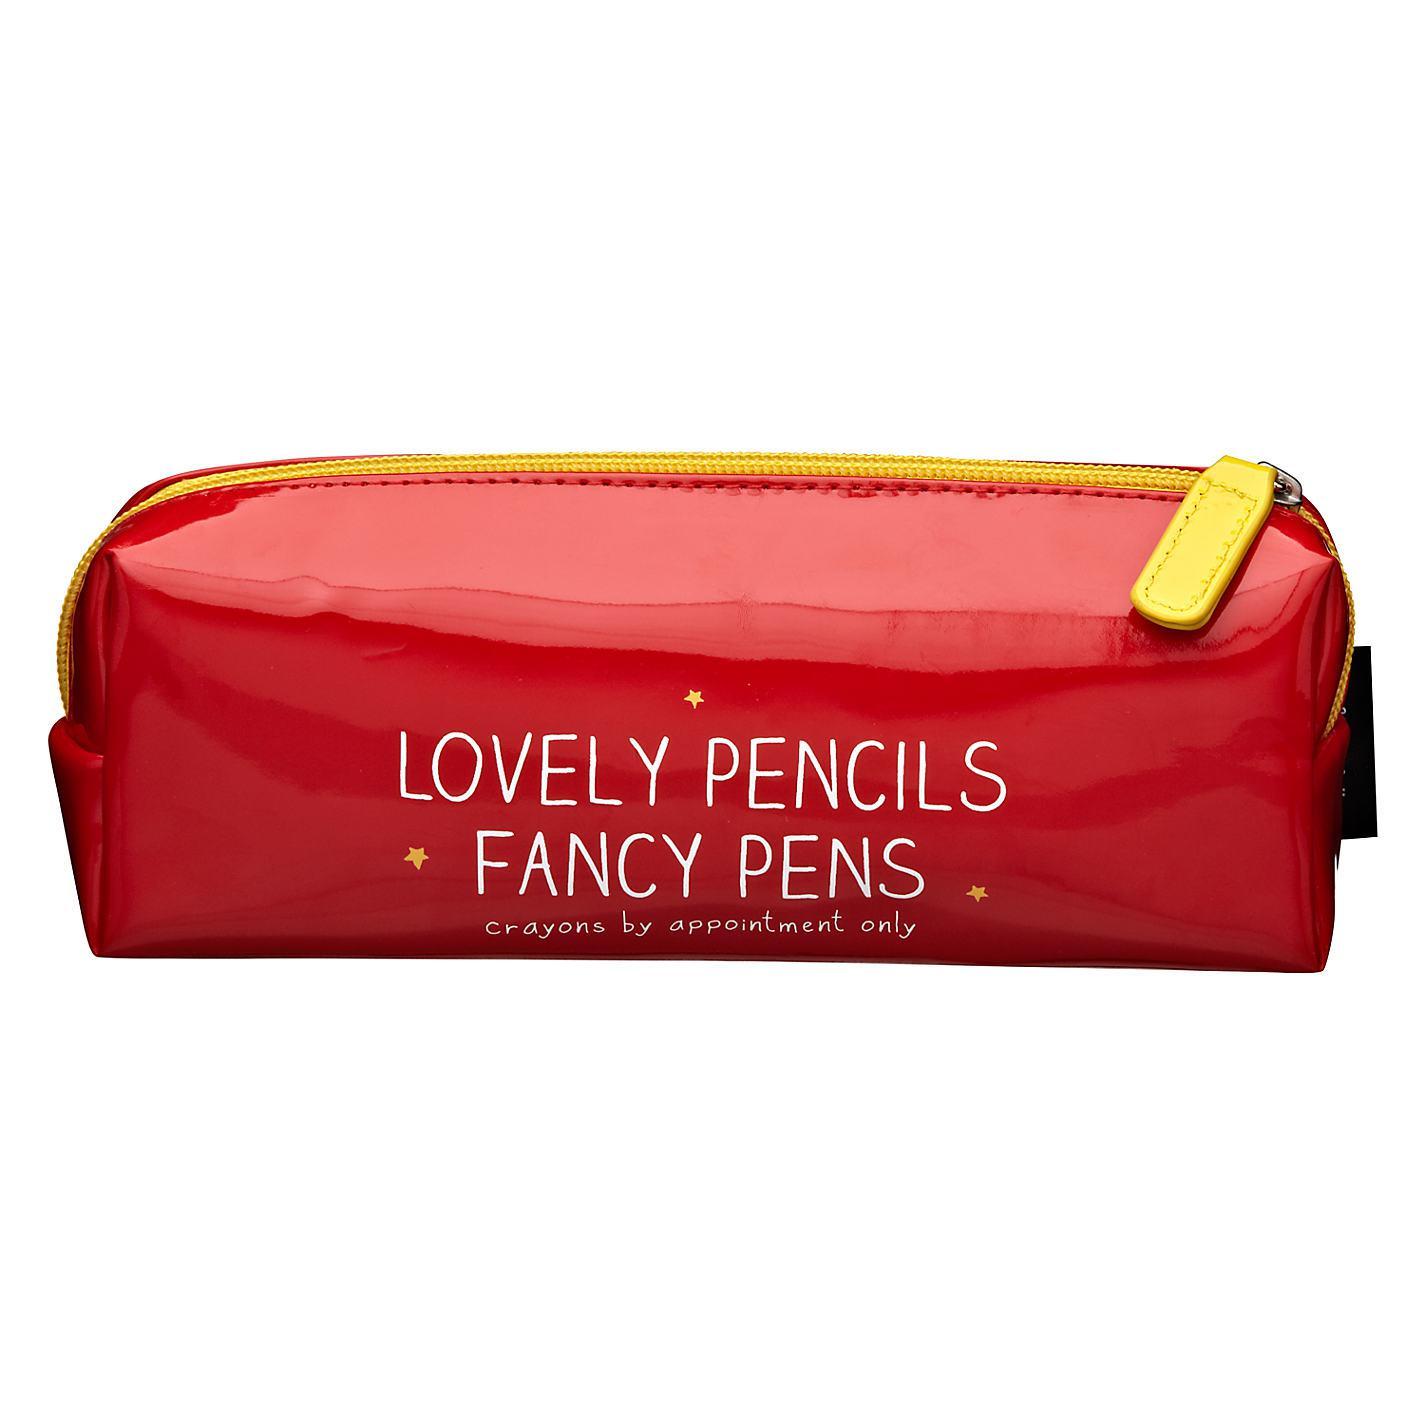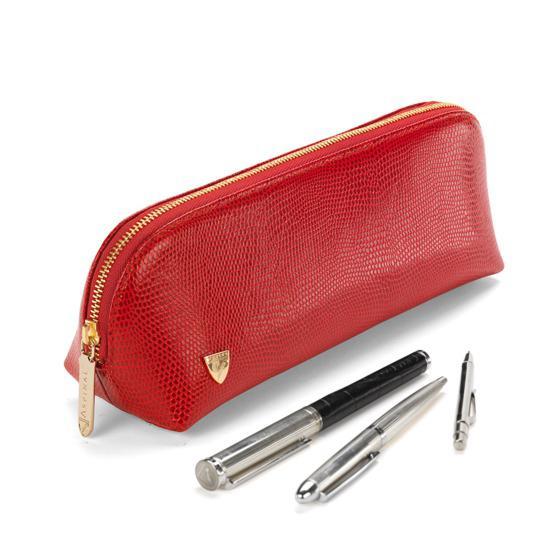The first image is the image on the left, the second image is the image on the right. Evaluate the accuracy of this statement regarding the images: "One image contains a closed red zippered case without any writing implements near it.". Is it true? Answer yes or no. Yes. 